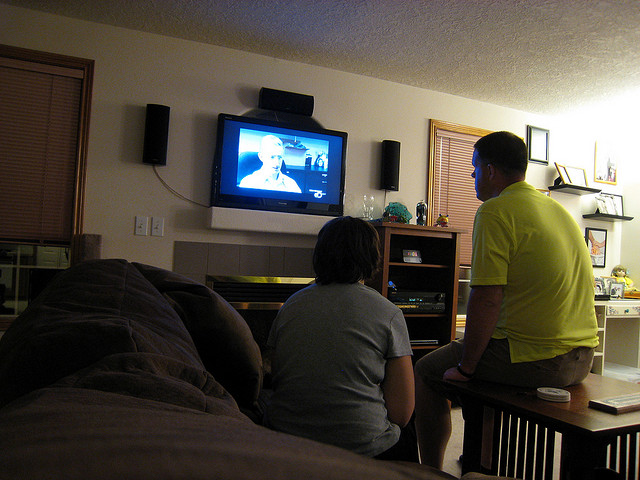<image>What is cast? It is ambiguous what 'cast' is referring to. It could be shadows, something from a television show or a news cast. What is cast? I am not sure what "cast" refers to in this context. It can be shadows, television show, or news. 